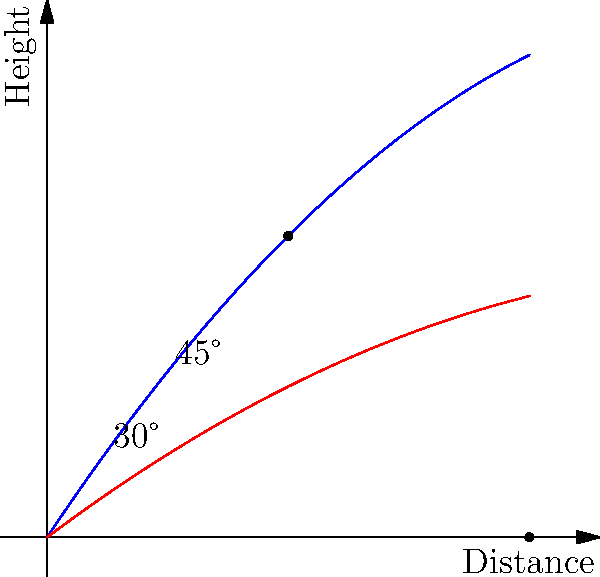Based on the graph showing two javelin trajectories, which launch angle results in the maximum distance, and what is that optimal angle for achieving the greatest throwing distance? To determine the optimal angle for launching a javelin to achieve maximum distance, we need to analyze the given graph and apply our knowledge of projectile motion. Let's break it down step-by-step:

1. The graph shows two trajectories: one in blue and one in red.
2. The blue trajectory reaches a higher peak and travels further than the red one.
3. The blue trajectory is labeled "45°", while the red one is labeled "30°".
4. In projectile motion, the optimal angle for achieving maximum distance on level ground is 45°.
5. This is because 45° provides the best balance between vertical and horizontal components of velocity.
6. At 45°, half of the initial velocity contributes to height, and half contributes to horizontal distance.
7. Angles lower than 45° (like 30°) don't achieve enough height for maximum distance.
8. Angles higher than 45° achieve more height but sacrifice horizontal distance.
9. The graph confirms this theory, as the 45° trajectory (blue) travels further than the 30° trajectory (red).

Therefore, based on both the graph and physics principles, the optimal angle for launching a javelin to achieve maximum distance is 45°.
Answer: 45° 